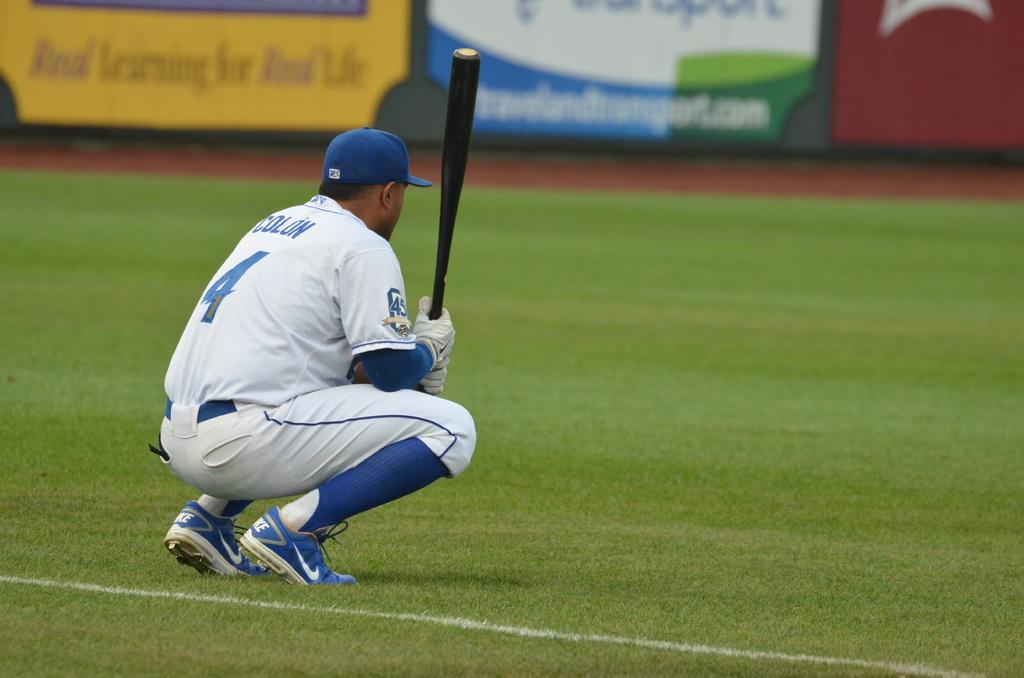<image>
Write a terse but informative summary of the picture. number 4 named colon squatting down while hold bat on baseball field 